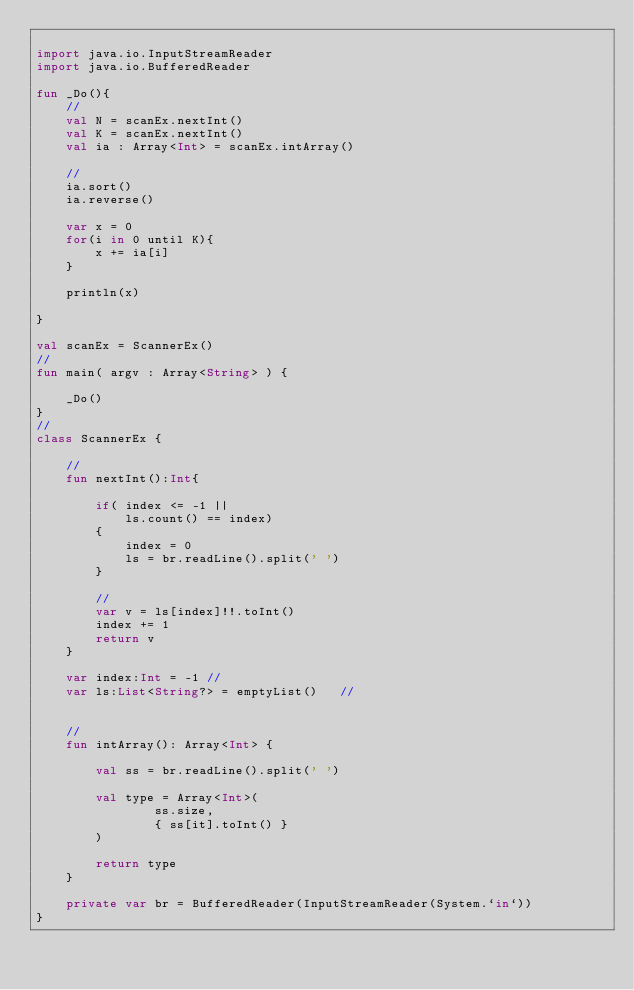Convert code to text. <code><loc_0><loc_0><loc_500><loc_500><_Kotlin_>
import java.io.InputStreamReader
import java.io.BufferedReader

fun _Do(){
    //
    val N = scanEx.nextInt()
    val K = scanEx.nextInt()
    val ia : Array<Int> = scanEx.intArray()
    
    //
    ia.sort()
    ia.reverse()
    
    var x = 0
    for(i in 0 until K){
        x += ia[i]
    }

    println(x)
    
}

val scanEx = ScannerEx()
//
fun main( argv : Array<String> ) {

    _Do()
}
//
class ScannerEx {
    
    //
    fun nextInt():Int{
        
        if( index <= -1 ||
            ls.count() == index)
        {
            index = 0
            ls = br.readLine().split(' ')
        }

        //
        var v = ls[index]!!.toInt()
        index += 1
        return v
    }
    
    var index:Int = -1 //
    var ls:List<String?> = emptyList()   //
    
    
    //
    fun intArray(): Array<Int> {
        
        val ss = br.readLine().split(' ')
        
        val type = Array<Int>(
                ss.size,
                { ss[it].toInt() }
        )
        
        return type
    }
    
    private var br = BufferedReader(InputStreamReader(System.`in`))
}


</code> 